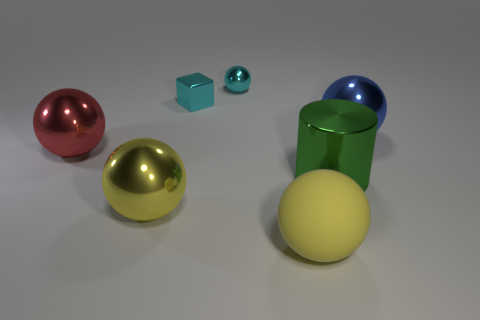Add 3 big blue matte balls. How many objects exist? 10 Subtract 1 cylinders. How many cylinders are left? 0 Subtract all blue blocks. Subtract all big yellow shiny spheres. How many objects are left? 6 Add 7 small cyan cubes. How many small cyan cubes are left? 8 Add 6 small green shiny cylinders. How many small green shiny cylinders exist? 6 Subtract all red spheres. How many spheres are left? 4 Subtract all big yellow rubber spheres. How many spheres are left? 4 Subtract 0 gray balls. How many objects are left? 7 Subtract all cylinders. How many objects are left? 6 Subtract all brown cylinders. Subtract all blue blocks. How many cylinders are left? 1 